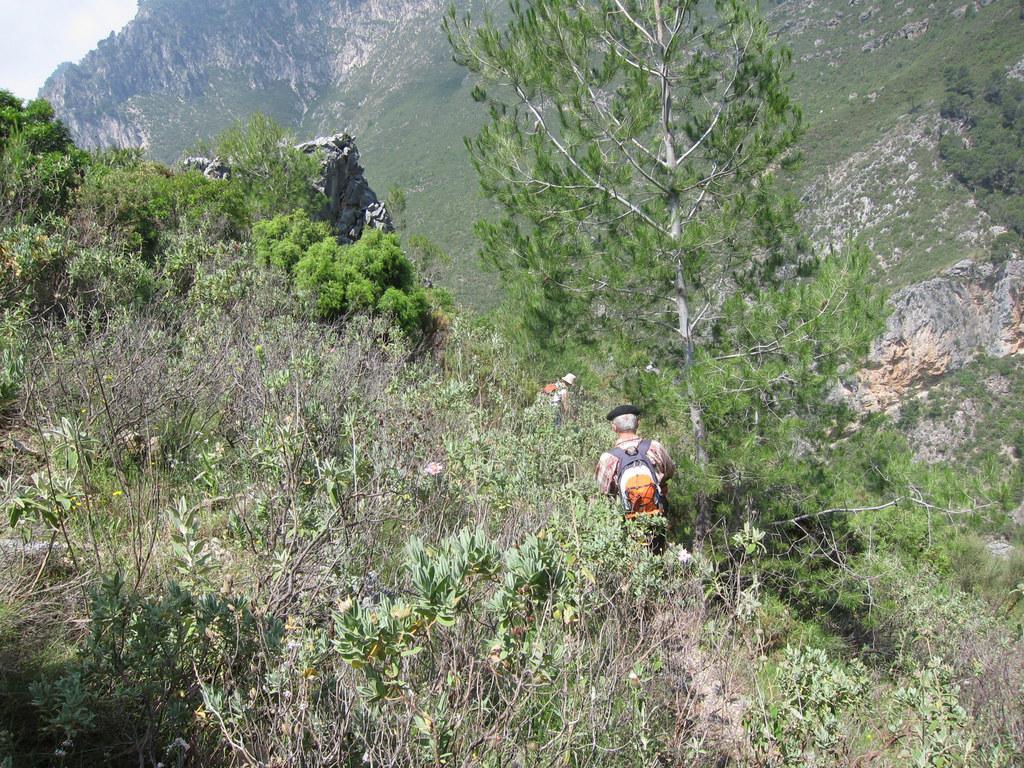Describe this image in one or two sentences. In this picture we can see two people and in the background we can see trees, rocks, sky. 